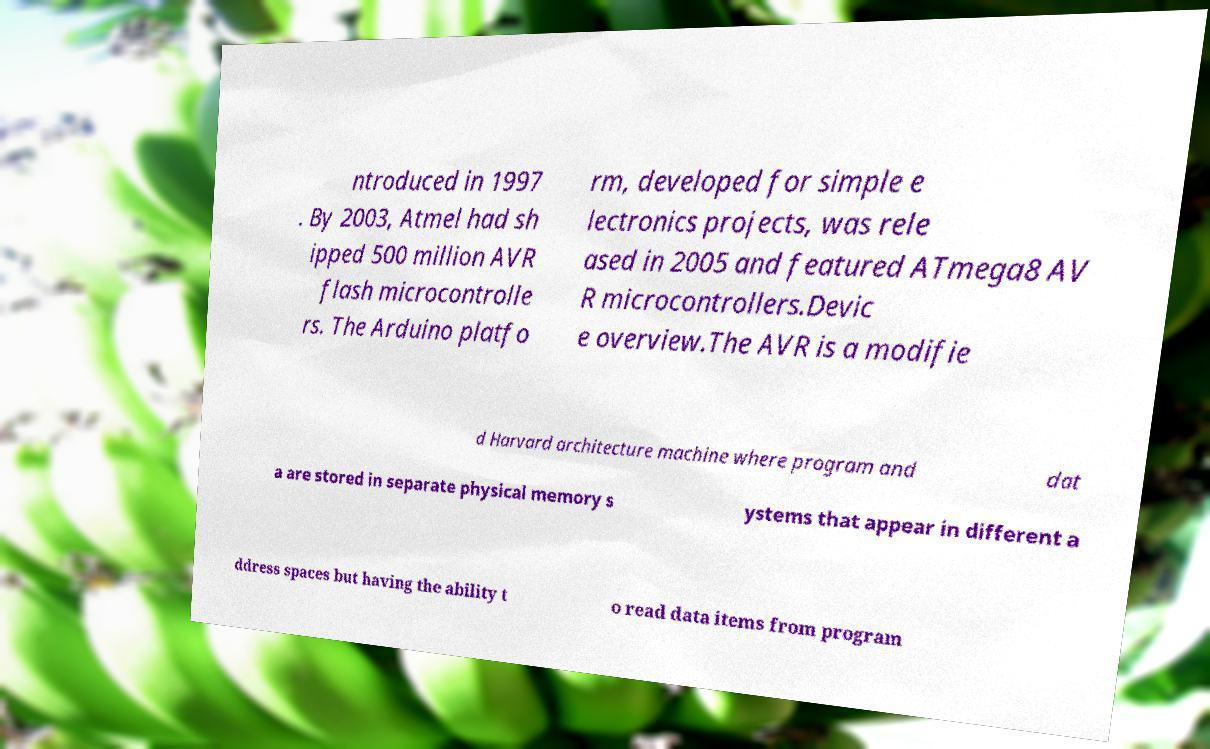Can you accurately transcribe the text from the provided image for me? ntroduced in 1997 . By 2003, Atmel had sh ipped 500 million AVR flash microcontrolle rs. The Arduino platfo rm, developed for simple e lectronics projects, was rele ased in 2005 and featured ATmega8 AV R microcontrollers.Devic e overview.The AVR is a modifie d Harvard architecture machine where program and dat a are stored in separate physical memory s ystems that appear in different a ddress spaces but having the ability t o read data items from program 